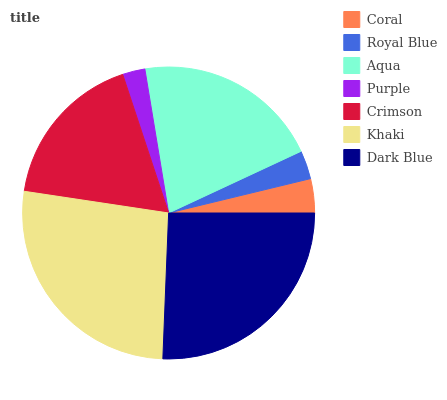Is Purple the minimum?
Answer yes or no. Yes. Is Khaki the maximum?
Answer yes or no. Yes. Is Royal Blue the minimum?
Answer yes or no. No. Is Royal Blue the maximum?
Answer yes or no. No. Is Coral greater than Royal Blue?
Answer yes or no. Yes. Is Royal Blue less than Coral?
Answer yes or no. Yes. Is Royal Blue greater than Coral?
Answer yes or no. No. Is Coral less than Royal Blue?
Answer yes or no. No. Is Crimson the high median?
Answer yes or no. Yes. Is Crimson the low median?
Answer yes or no. Yes. Is Aqua the high median?
Answer yes or no. No. Is Aqua the low median?
Answer yes or no. No. 